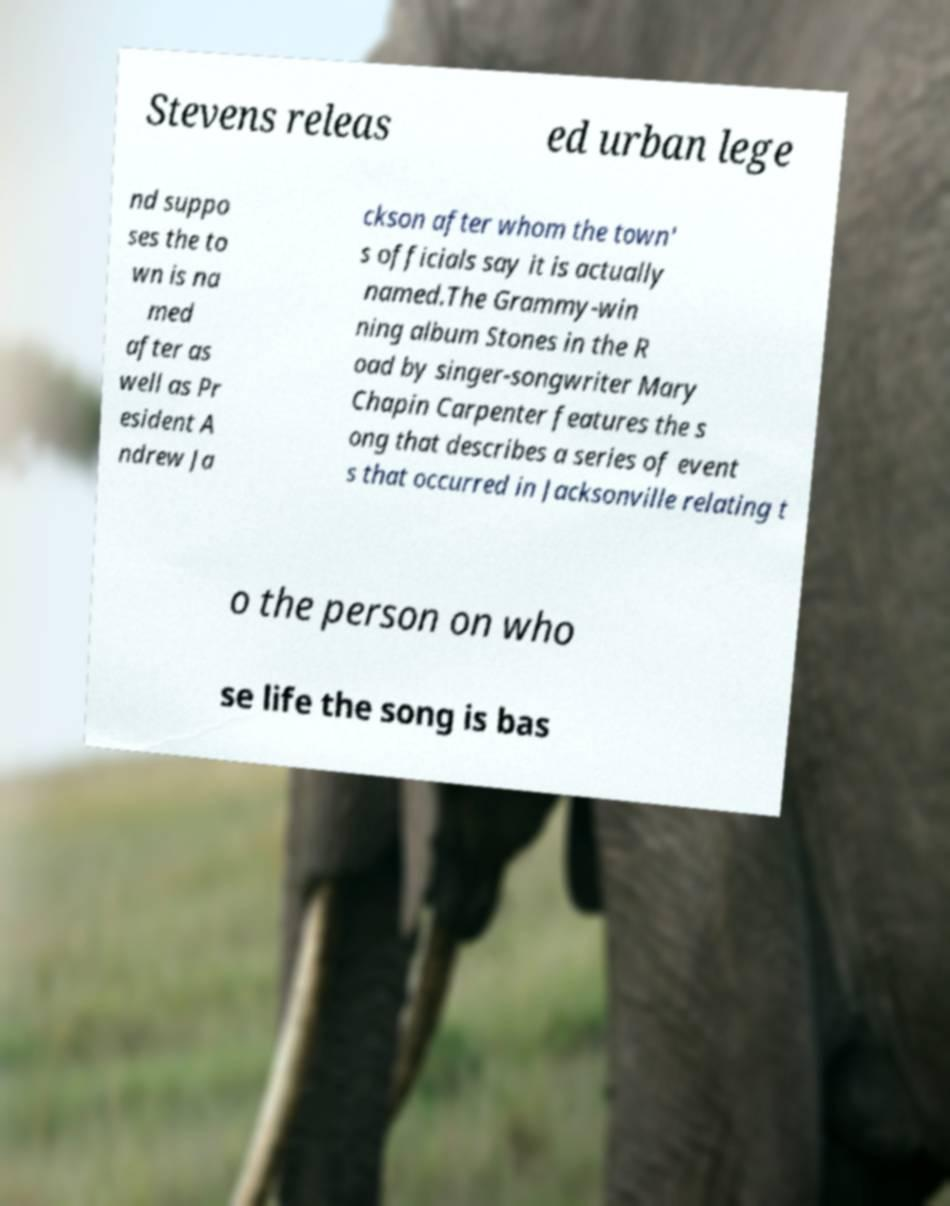I need the written content from this picture converted into text. Can you do that? Stevens releas ed urban lege nd suppo ses the to wn is na med after as well as Pr esident A ndrew Ja ckson after whom the town' s officials say it is actually named.The Grammy-win ning album Stones in the R oad by singer-songwriter Mary Chapin Carpenter features the s ong that describes a series of event s that occurred in Jacksonville relating t o the person on who se life the song is bas 